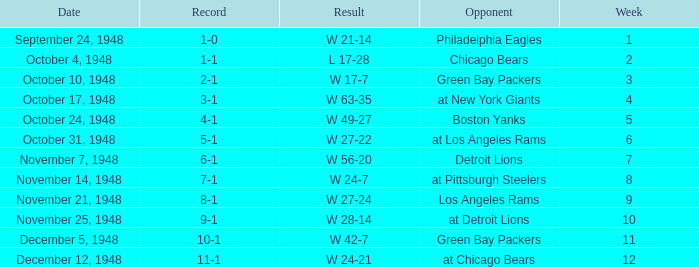What was the record for December 5, 1948? 10-1. 